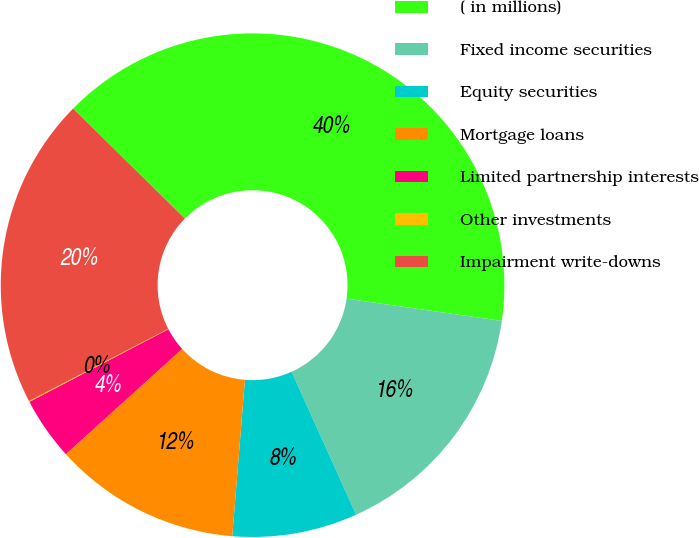Convert chart to OTSL. <chart><loc_0><loc_0><loc_500><loc_500><pie_chart><fcel>( in millions)<fcel>Fixed income securities<fcel>Equity securities<fcel>Mortgage loans<fcel>Limited partnership interests<fcel>Other investments<fcel>Impairment write-downs<nl><fcel>39.89%<fcel>15.99%<fcel>8.03%<fcel>12.01%<fcel>4.04%<fcel>0.06%<fcel>19.98%<nl></chart> 